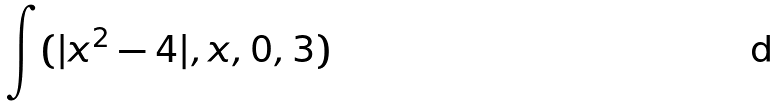Convert formula to latex. <formula><loc_0><loc_0><loc_500><loc_500>\int ( | x ^ { 2 } - 4 | , x , 0 , 3 )</formula> 